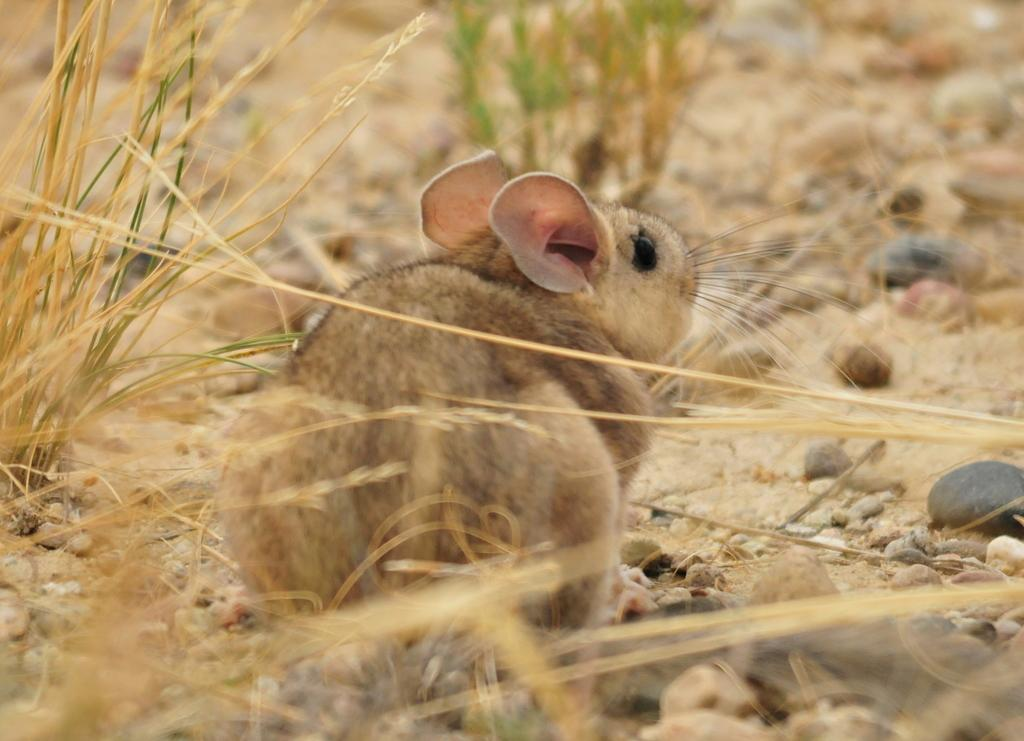What animal can be seen on the path in the image? There is a rat on the path in the image. What is located in front of the art in the image? There are stones and grass in front of the art in the image. What is the level of wealth depicted in the image? The image does not depict any wealth or financial status; it features a rat on a path and stones and grass in front of art. 